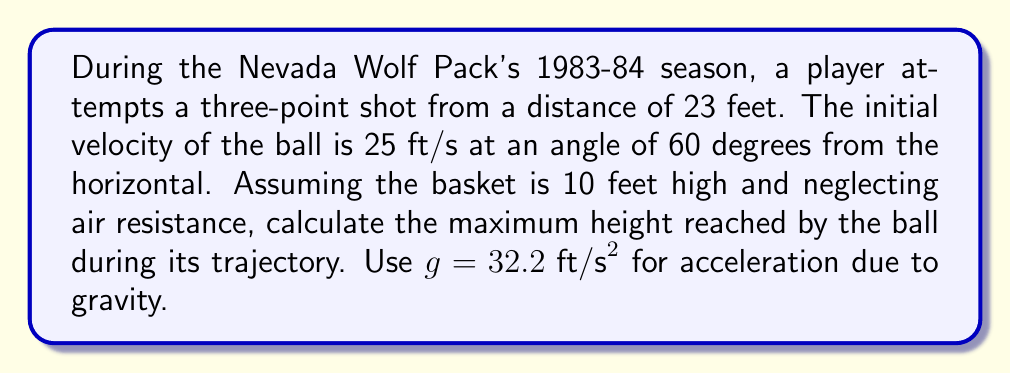What is the answer to this math problem? To solve this problem, we'll use the equations of motion for projectile motion, which describe the nonlinear trajectory of the basketball.

1. First, let's break down the initial velocity into its horizontal and vertical components:
   $v_{0x} = v_0 \cos \theta = 25 \cos 60° = 12.5 \text{ ft/s}$
   $v_{0y} = v_0 \sin \theta = 25 \sin 60° = 21.65 \text{ ft/s}$

2. The time to reach maximum height is when the vertical velocity becomes zero:
   $v_y = v_{0y} - gt = 0$
   $t = \frac{v_{0y}}{g} = \frac{21.65}{32.2} = 0.672 \text{ s}$

3. Now we can calculate the maximum height using the equation:
   $y = y_0 + v_{0y}t - \frac{1}{2}gt^2$

   Where $y_0$ is the initial height (assumed to be the player's release height, approximately 7 feet):

   $y_{max} = 7 + 21.65(0.672) - \frac{1}{2}(32.2)(0.672)^2$

4. Simplifying:
   $y_{max} = 7 + 14.55 - 7.28 = 14.27 \text{ ft}$

5. The maximum height reached by the ball is 14.27 feet above the ground.

[asy]
import graph;
size(200,150);
real f(real x) {return -0.05*x^2 + 0.9*x + 7;}
draw(graph(f,0,23),blue);
draw((0,10)--(23,10),dashed);
draw((0,14.27)--(23,14.27),red);
label("10 ft",(-1,10),W);
label("14.27 ft",(-1,14.27),W);
label("23 ft",(23,0),S);
[/asy]
Answer: 14.27 feet 